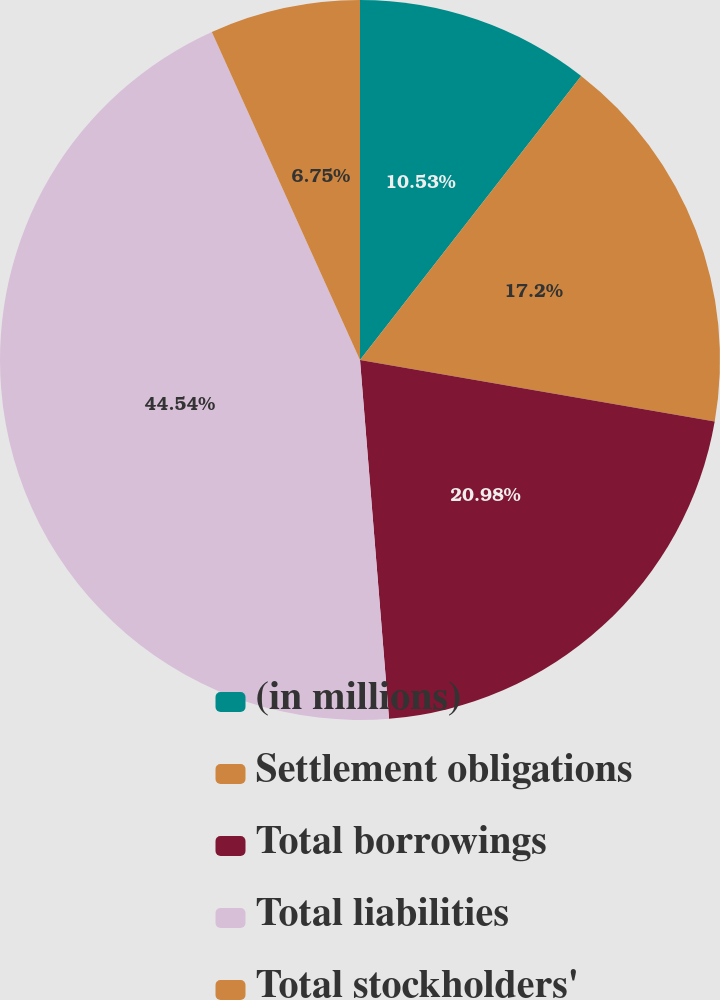<chart> <loc_0><loc_0><loc_500><loc_500><pie_chart><fcel>(in millions)<fcel>Settlement obligations<fcel>Total borrowings<fcel>Total liabilities<fcel>Total stockholders'<nl><fcel>10.53%<fcel>17.2%<fcel>20.98%<fcel>44.53%<fcel>6.75%<nl></chart> 